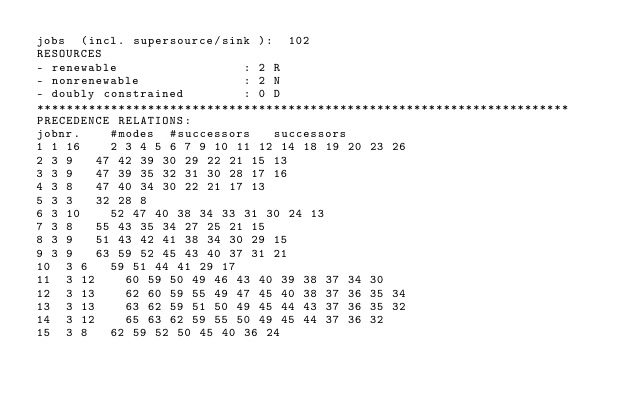<code> <loc_0><loc_0><loc_500><loc_500><_ObjectiveC_>jobs  (incl. supersource/sink ):	102
RESOURCES
- renewable                 : 2 R
- nonrenewable              : 2 N
- doubly constrained        : 0 D
************************************************************************
PRECEDENCE RELATIONS:
jobnr.    #modes  #successors   successors
1	1	16		2 3 4 5 6 7 9 10 11 12 14 18 19 20 23 26 
2	3	9		47 42 39 30 29 22 21 15 13 
3	3	9		47 39 35 32 31 30 28 17 16 
4	3	8		47 40 34 30 22 21 17 13 
5	3	3		32 28 8 
6	3	10		52 47 40 38 34 33 31 30 24 13 
7	3	8		55 43 35 34 27 25 21 15 
8	3	9		51 43 42 41 38 34 30 29 15 
9	3	9		63 59 52 45 43 40 37 31 21 
10	3	6		59 51 44 41 29 17 
11	3	12		60 59 50 49 46 43 40 39 38 37 34 30 
12	3	13		62 60 59 55 49 47 45 40 38 37 36 35 34 
13	3	13		63 62 59 51 50 49 45 44 43 37 36 35 32 
14	3	12		65 63 62 59 55 50 49 45 44 37 36 32 
15	3	8		62 59 52 50 45 40 36 24 </code> 